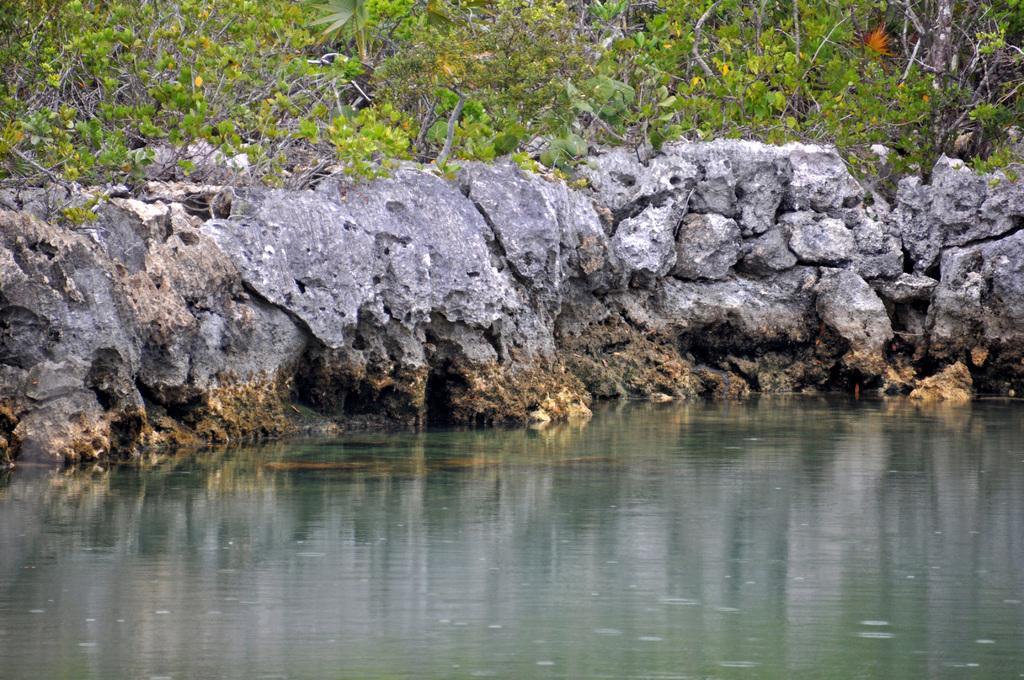Describe this image in one or two sentences. In this image we can see the trees, rocks and water. 